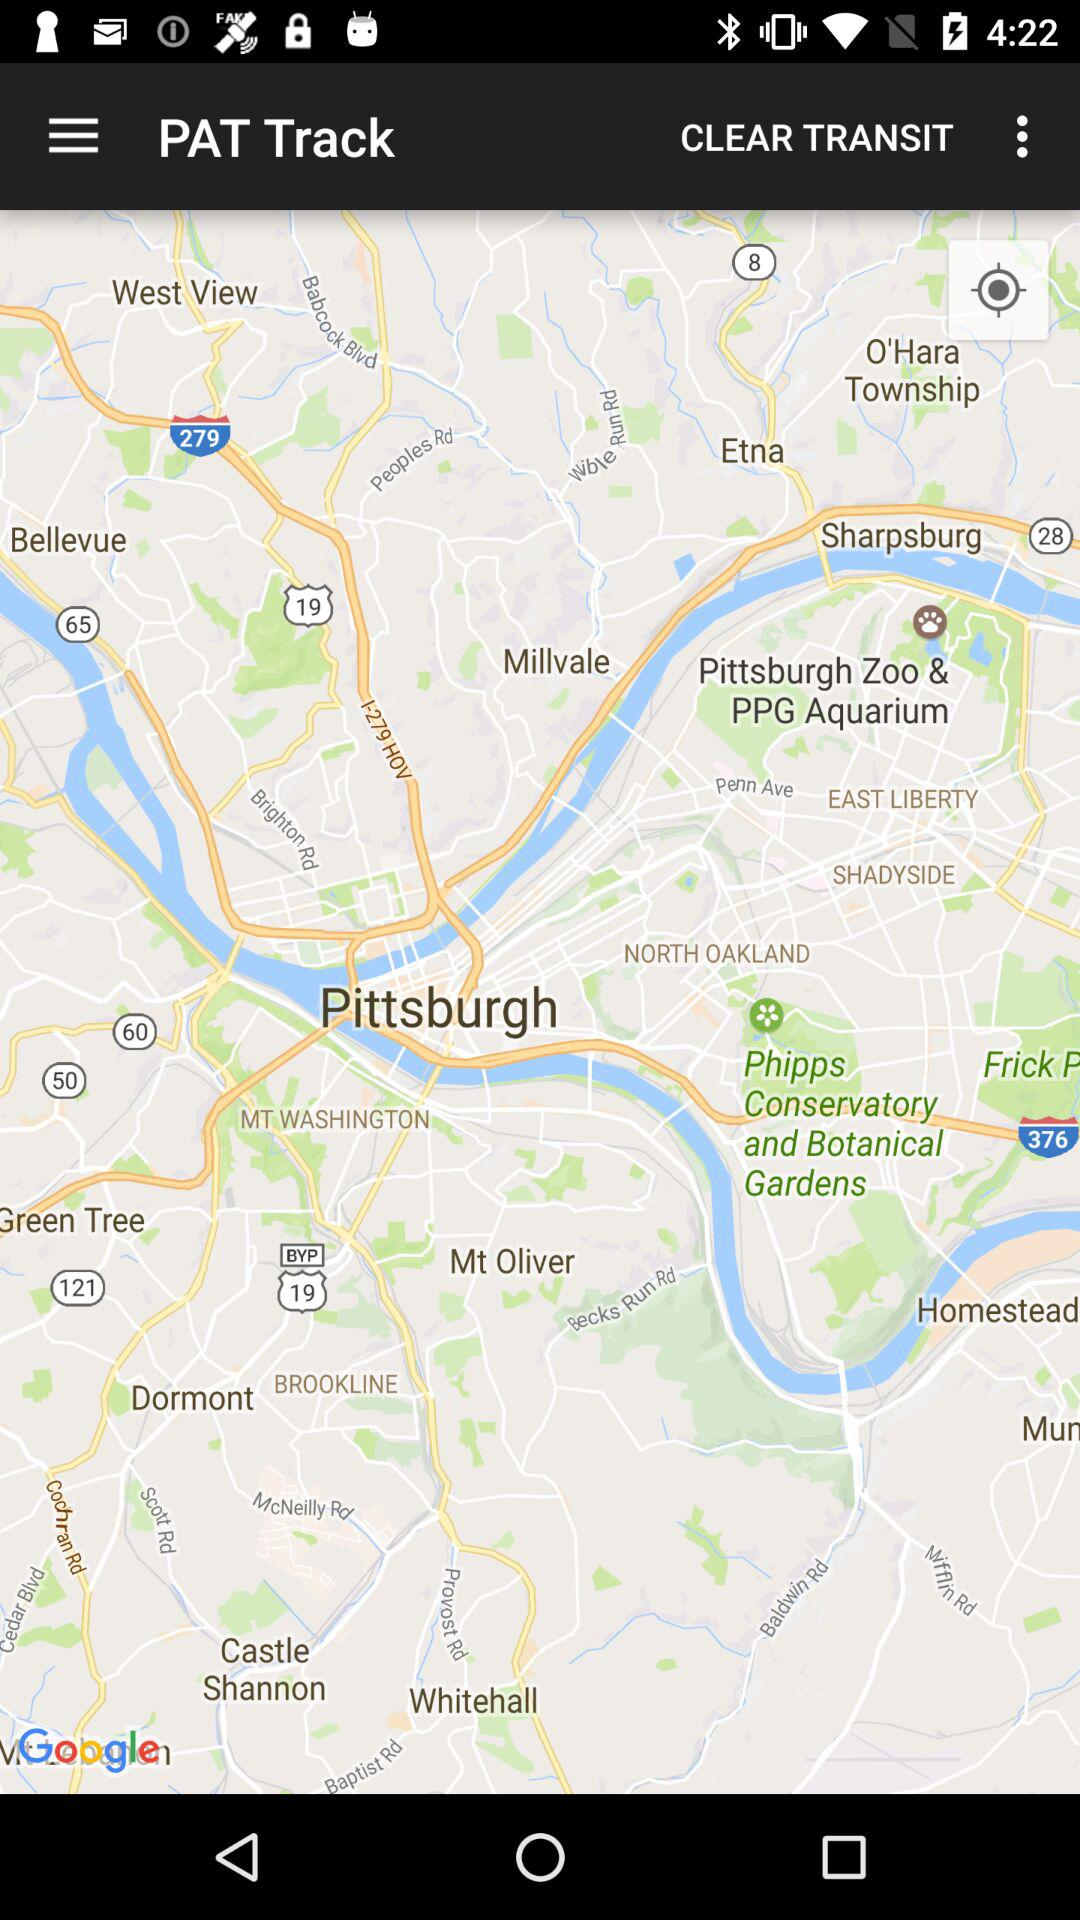What is the application name? The application name is "PAT Track". 